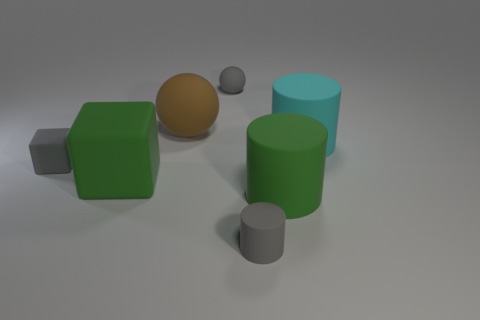How many objects are objects behind the small gray cube or large green things?
Your answer should be compact. 5. How many other objects are the same size as the gray cylinder?
Provide a short and direct response. 2. Is the number of tiny matte objects on the right side of the big brown thing the same as the number of gray matte things that are to the right of the big cyan rubber cylinder?
Your answer should be very brief. No. The other large object that is the same shape as the large cyan object is what color?
Offer a terse response. Green. Do the tiny object that is to the right of the small gray matte ball and the small block have the same color?
Ensure brevity in your answer.  Yes. What is the size of the other rubber thing that is the same shape as the big brown matte thing?
Your response must be concise. Small. What number of large yellow things have the same material as the small block?
Your answer should be very brief. 0. Are there any big green rubber objects on the left side of the large green matte object on the left side of the gray matte object that is in front of the gray matte cube?
Your response must be concise. No. There is a large cyan thing; what shape is it?
Your response must be concise. Cylinder. What number of large rubber objects have the same color as the big block?
Offer a terse response. 1. 